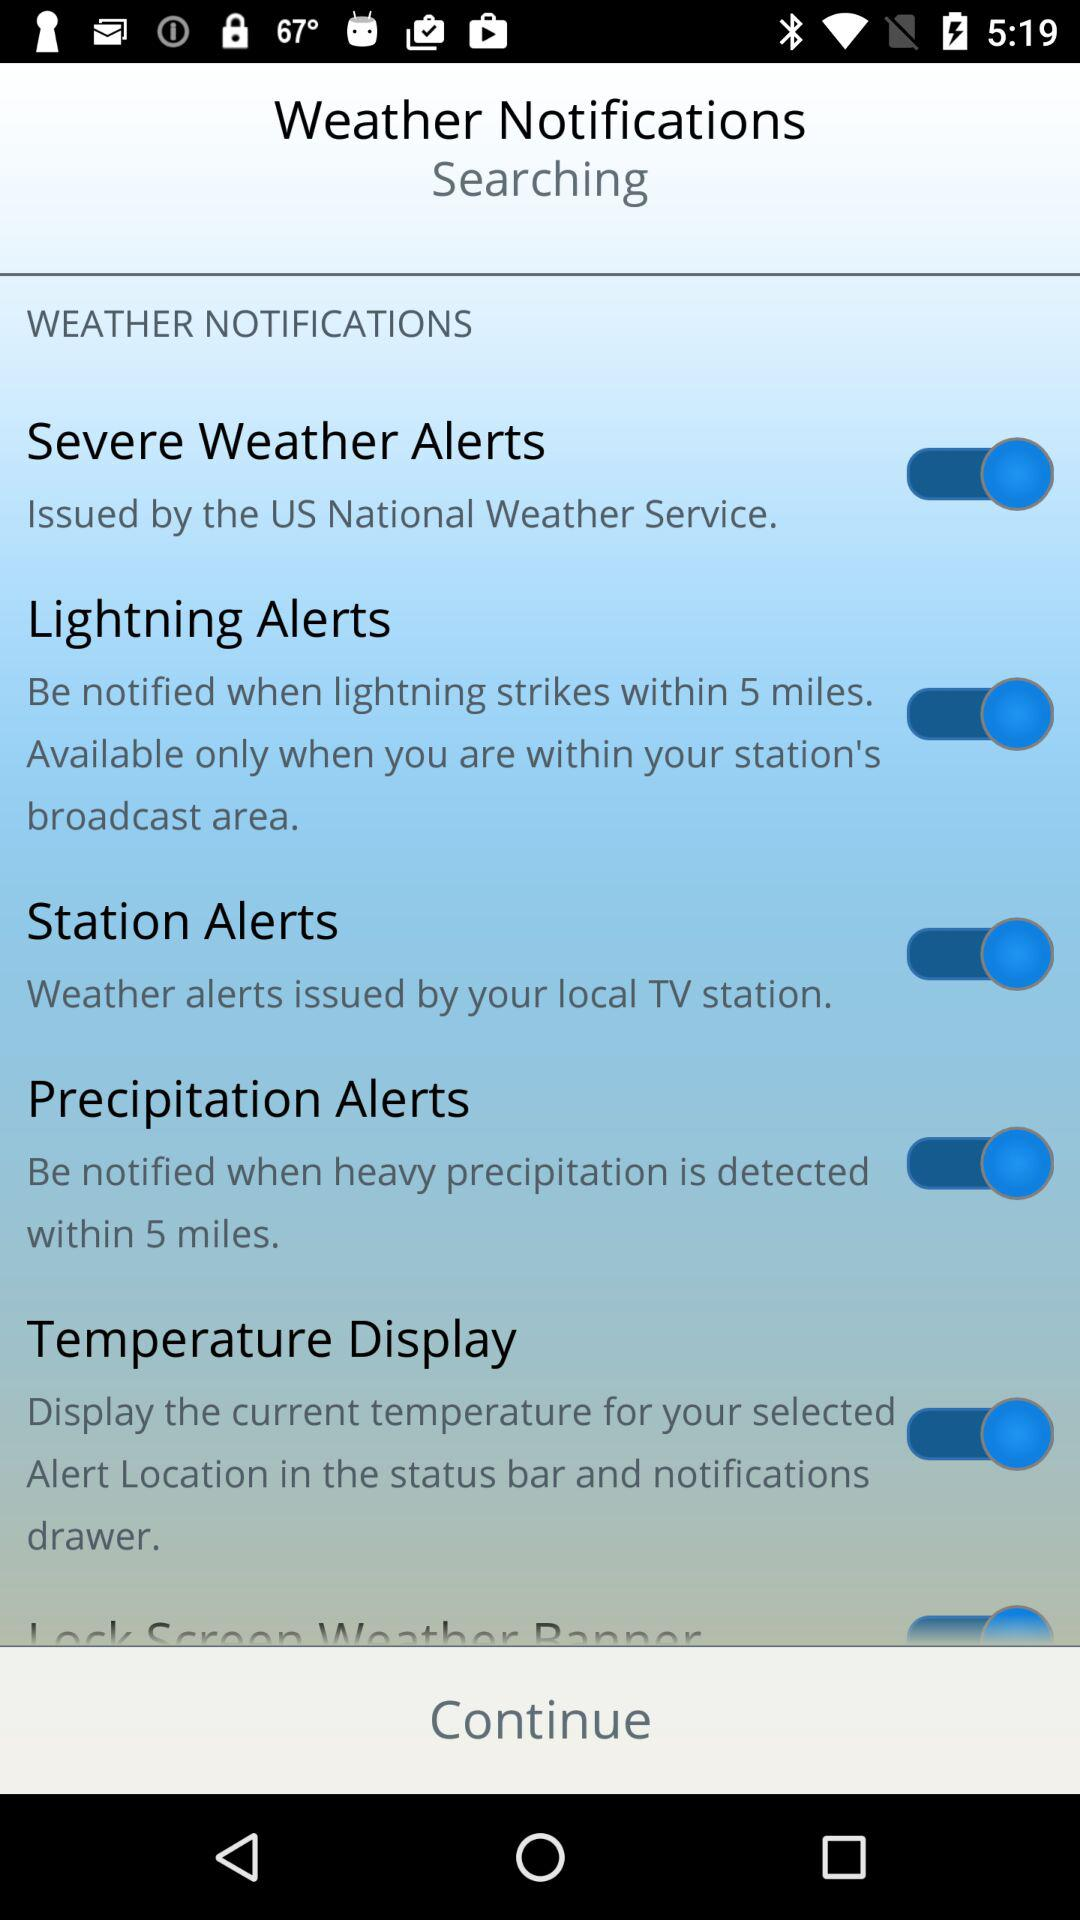Which alerts are "on"? The alerts that are "on" are "Severe Weather Alerts", "Lightning Alerts", "Station Alerts" and "Precipitation Alerts". 